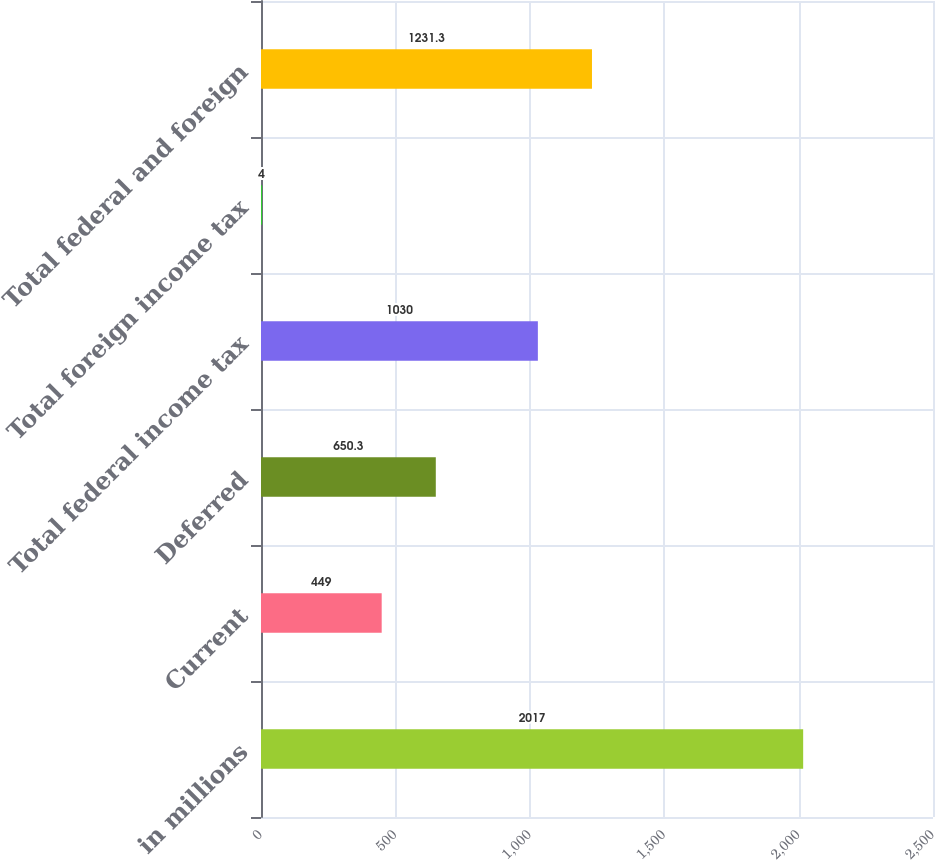Convert chart to OTSL. <chart><loc_0><loc_0><loc_500><loc_500><bar_chart><fcel>in millions<fcel>Current<fcel>Deferred<fcel>Total federal income tax<fcel>Total foreign income tax<fcel>Total federal and foreign<nl><fcel>2017<fcel>449<fcel>650.3<fcel>1030<fcel>4<fcel>1231.3<nl></chart> 